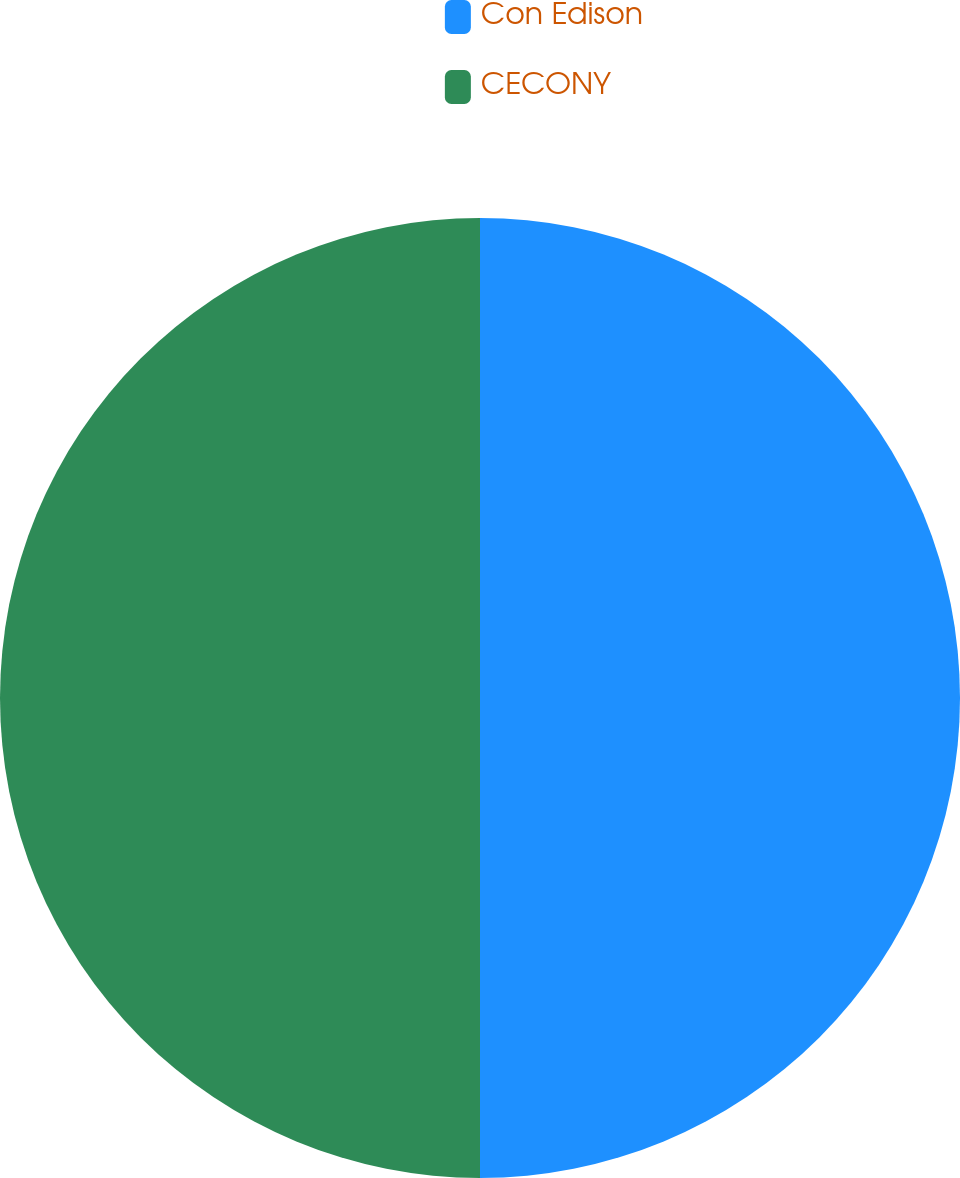<chart> <loc_0><loc_0><loc_500><loc_500><pie_chart><fcel>Con Edison<fcel>CECONY<nl><fcel>50.0%<fcel>50.0%<nl></chart> 